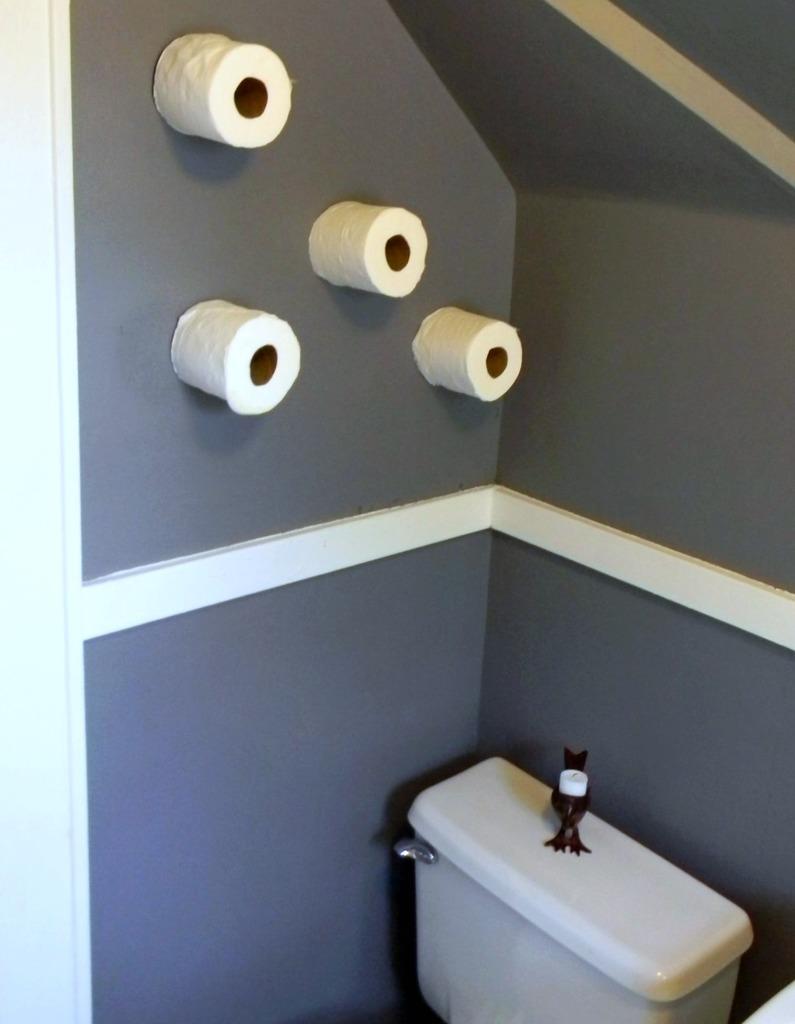Describe this image in one or two sentences. At the bottom of the image there is a flush. And on the wall there are tissue rolls. 